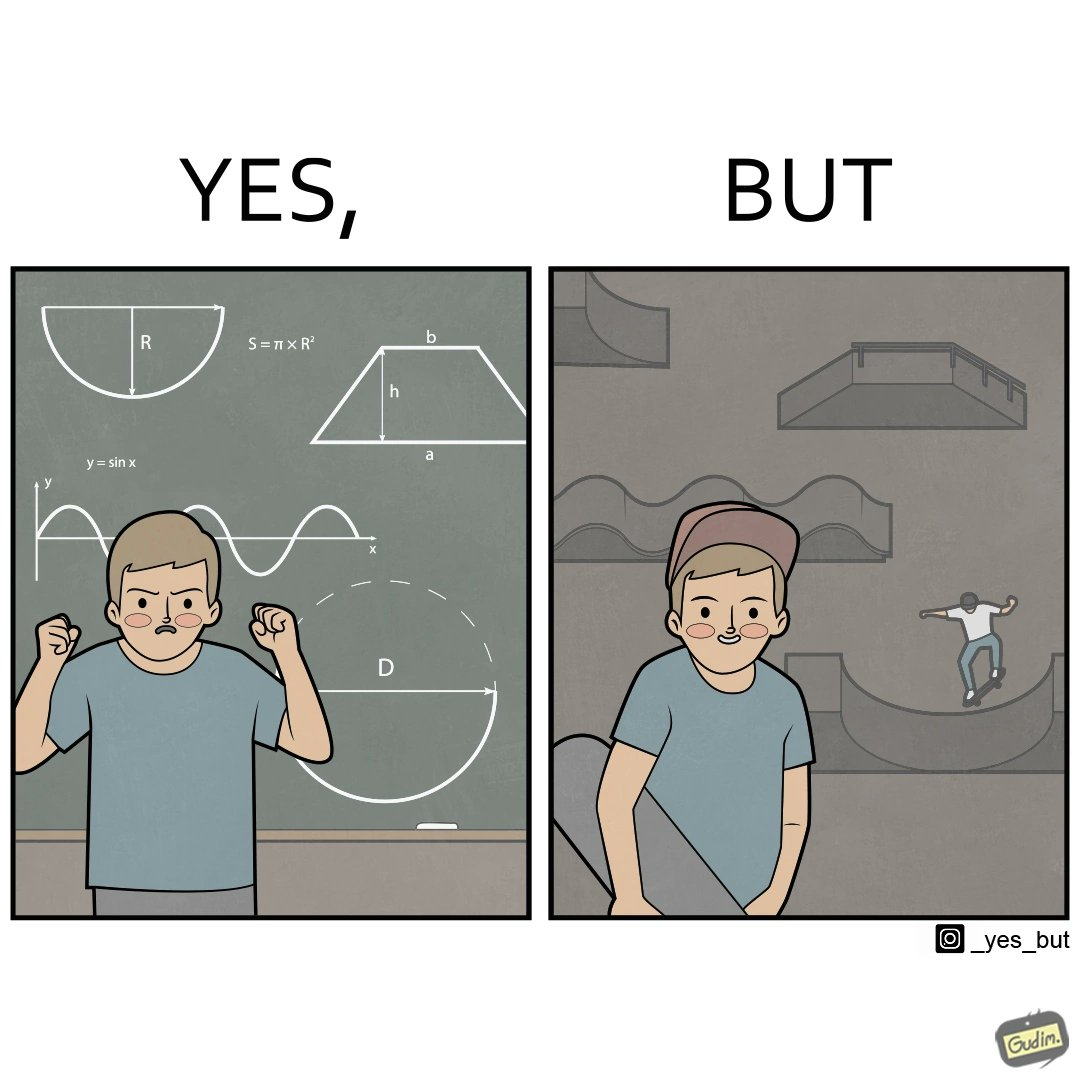Is this image satirical or non-satirical? Yes, this image is satirical. 